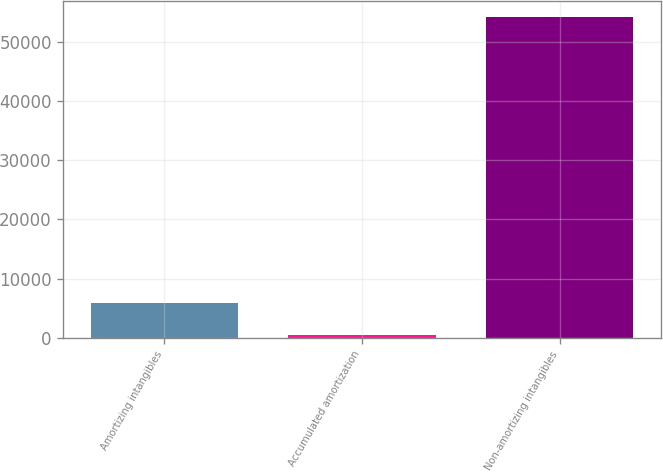Convert chart to OTSL. <chart><loc_0><loc_0><loc_500><loc_500><bar_chart><fcel>Amortizing intangibles<fcel>Accumulated amortization<fcel>Non-amortizing intangibles<nl><fcel>5911.7<fcel>553<fcel>54140<nl></chart> 